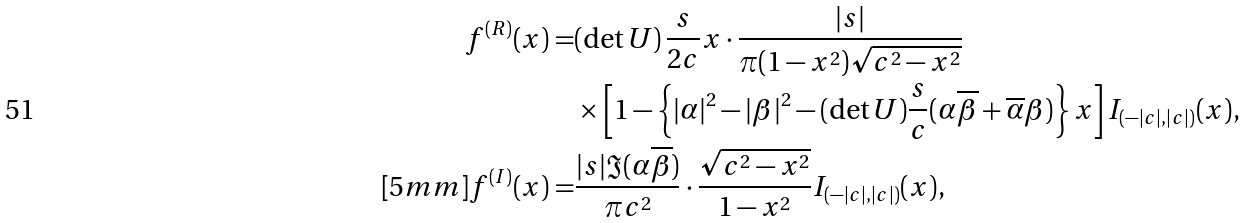Convert formula to latex. <formula><loc_0><loc_0><loc_500><loc_500>f ^ { ( R ) } ( x ) = & ( \det U ) \, \frac { s } { 2 c } x \cdot \frac { | s | } { \pi ( 1 - x ^ { 2 } ) \sqrt { c ^ { 2 } - x ^ { 2 } } } \\ & \times \left [ 1 - \left \{ | \alpha | ^ { 2 } - | \beta | ^ { 2 } - ( \det U ) \frac { s } { c } ( \alpha \overline { \beta } + \overline { \alpha } \beta ) \right \} x \right ] I _ { ( - | c | , | c | ) } ( x ) , \\ [ 5 m m ] f ^ { ( I ) } ( x ) = & \frac { | s | \Im ( \alpha \overline { \beta } ) } { \pi c ^ { 2 } } \cdot \frac { \sqrt { c ^ { 2 } - x ^ { 2 } } } { 1 - x ^ { 2 } } I _ { ( - | c | , | c | ) } ( x ) ,</formula> 